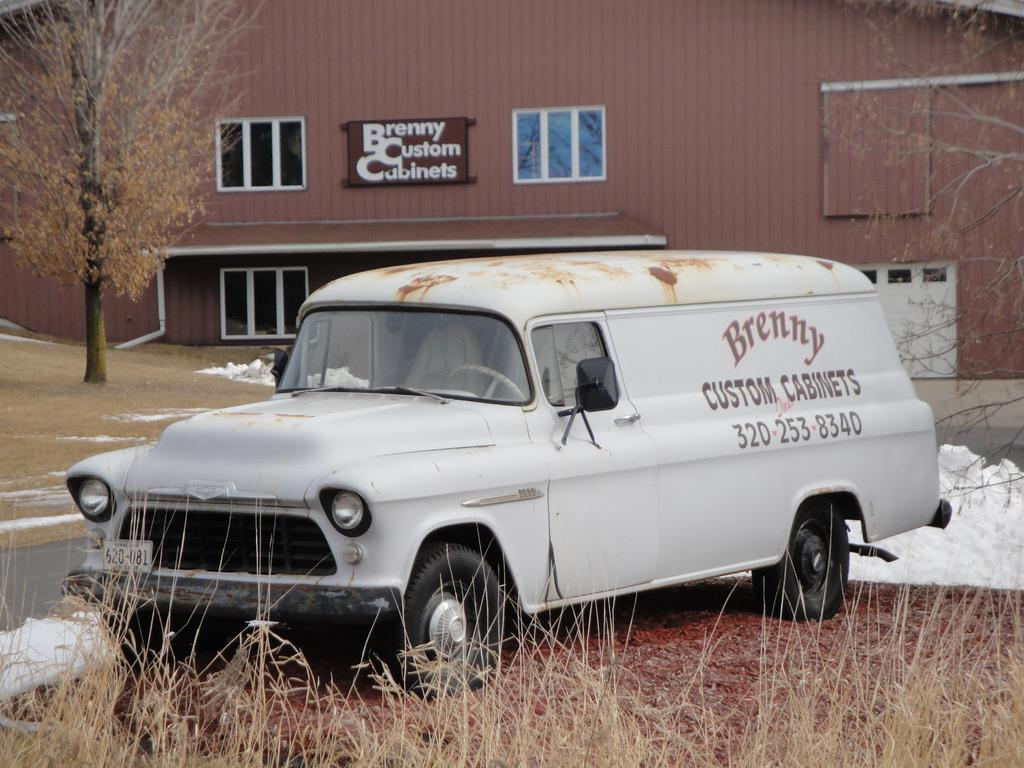What is the main subject in the image? There is a vehicle in the image. What type of vegetation can be seen in the image? There is dried grass in the image. What structures are visible in the background of the image? There is a shed, windows, a board, and trees in the background of the image. Can you see a rabbit hopping around the vehicle in the image? There is no rabbit present in the image. What type of prison can be seen in the background of the image? There is no prison present in the image; only a shed, windows, a board, and trees are visible in the background. 